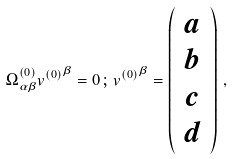<formula> <loc_0><loc_0><loc_500><loc_500>\Omega ^ { ( 0 ) } _ { \alpha \beta } { v ^ { ( 0 ) } } ^ { \beta } = 0 \, ; \, { v ^ { ( 0 ) } } ^ { \beta } = \left ( \begin{array} { c } a \\ b \\ c \\ d \end{array} \right ) \, ,</formula> 